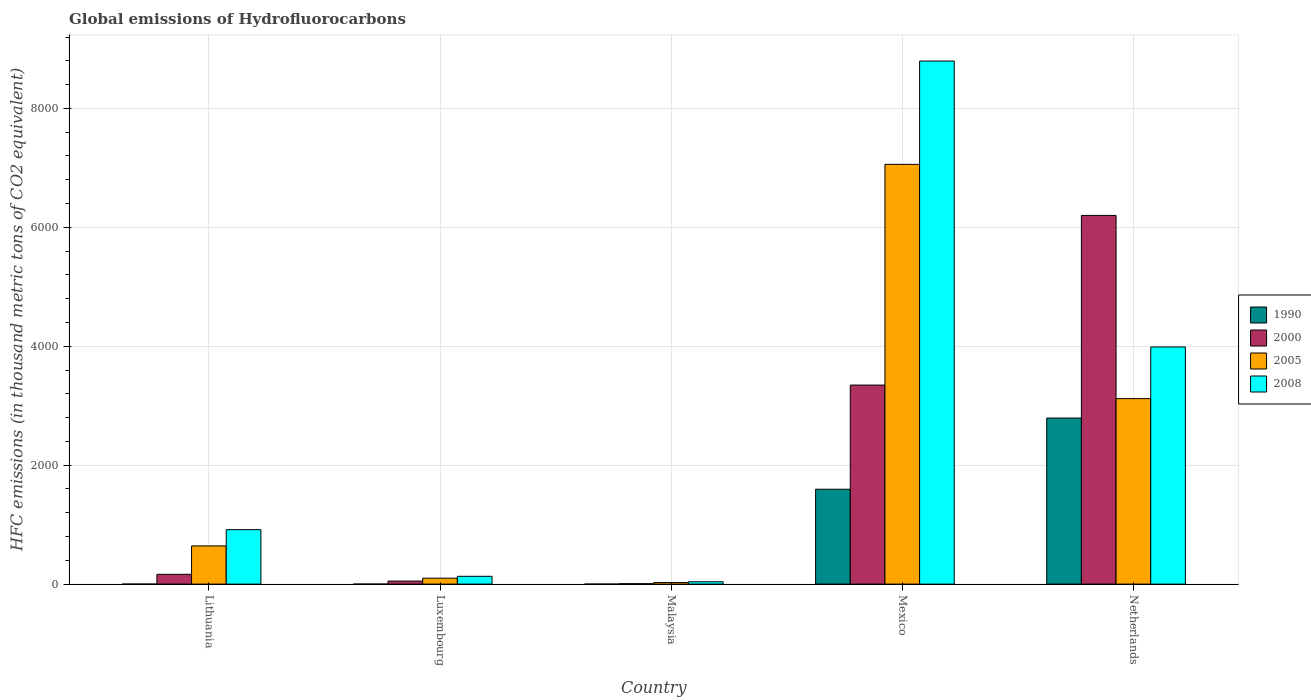Are the number of bars per tick equal to the number of legend labels?
Your response must be concise. Yes. What is the label of the 2nd group of bars from the left?
Your answer should be compact. Luxembourg. What is the global emissions of Hydrofluorocarbons in 2000 in Luxembourg?
Your answer should be compact. 51.1. Across all countries, what is the maximum global emissions of Hydrofluorocarbons in 2005?
Provide a succinct answer. 7058.9. In which country was the global emissions of Hydrofluorocarbons in 2008 minimum?
Keep it short and to the point. Malaysia. What is the total global emissions of Hydrofluorocarbons in 1990 in the graph?
Give a very brief answer. 4388.5. What is the difference between the global emissions of Hydrofluorocarbons in 1990 in Malaysia and that in Netherlands?
Give a very brief answer. -2792.8. What is the difference between the global emissions of Hydrofluorocarbons in 2008 in Malaysia and the global emissions of Hydrofluorocarbons in 2005 in Mexico?
Ensure brevity in your answer.  -7019.7. What is the average global emissions of Hydrofluorocarbons in 1990 per country?
Give a very brief answer. 877.7. What is the difference between the global emissions of Hydrofluorocarbons of/in 1990 and global emissions of Hydrofluorocarbons of/in 2000 in Malaysia?
Provide a succinct answer. -6.8. What is the ratio of the global emissions of Hydrofluorocarbons in 1990 in Lithuania to that in Netherlands?
Your answer should be very brief. 3.580507715994128e-5. Is the difference between the global emissions of Hydrofluorocarbons in 1990 in Luxembourg and Malaysia greater than the difference between the global emissions of Hydrofluorocarbons in 2000 in Luxembourg and Malaysia?
Offer a terse response. No. What is the difference between the highest and the second highest global emissions of Hydrofluorocarbons in 2005?
Your answer should be compact. 6416.8. What is the difference between the highest and the lowest global emissions of Hydrofluorocarbons in 2008?
Offer a terse response. 8757.7. In how many countries, is the global emissions of Hydrofluorocarbons in 2005 greater than the average global emissions of Hydrofluorocarbons in 2005 taken over all countries?
Make the answer very short. 2. What does the 2nd bar from the left in Lithuania represents?
Ensure brevity in your answer.  2000. How many bars are there?
Provide a short and direct response. 20. What is the difference between two consecutive major ticks on the Y-axis?
Provide a short and direct response. 2000. Does the graph contain any zero values?
Provide a short and direct response. No. What is the title of the graph?
Provide a succinct answer. Global emissions of Hydrofluorocarbons. What is the label or title of the Y-axis?
Make the answer very short. HFC emissions (in thousand metric tons of CO2 equivalent). What is the HFC emissions (in thousand metric tons of CO2 equivalent) of 1990 in Lithuania?
Your answer should be compact. 0.1. What is the HFC emissions (in thousand metric tons of CO2 equivalent) in 2000 in Lithuania?
Ensure brevity in your answer.  164.5. What is the HFC emissions (in thousand metric tons of CO2 equivalent) in 2005 in Lithuania?
Give a very brief answer. 642.1. What is the HFC emissions (in thousand metric tons of CO2 equivalent) in 2008 in Lithuania?
Provide a succinct answer. 915.7. What is the HFC emissions (in thousand metric tons of CO2 equivalent) of 1990 in Luxembourg?
Provide a short and direct response. 0.1. What is the HFC emissions (in thousand metric tons of CO2 equivalent) of 2000 in Luxembourg?
Your answer should be very brief. 51.1. What is the HFC emissions (in thousand metric tons of CO2 equivalent) in 2005 in Luxembourg?
Provide a succinct answer. 99.5. What is the HFC emissions (in thousand metric tons of CO2 equivalent) of 2008 in Luxembourg?
Provide a short and direct response. 131.2. What is the HFC emissions (in thousand metric tons of CO2 equivalent) of 1990 in Malaysia?
Provide a succinct answer. 0.1. What is the HFC emissions (in thousand metric tons of CO2 equivalent) in 2005 in Malaysia?
Offer a very short reply. 26.1. What is the HFC emissions (in thousand metric tons of CO2 equivalent) of 2008 in Malaysia?
Your answer should be very brief. 39.2. What is the HFC emissions (in thousand metric tons of CO2 equivalent) of 1990 in Mexico?
Make the answer very short. 1595.3. What is the HFC emissions (in thousand metric tons of CO2 equivalent) in 2000 in Mexico?
Keep it short and to the point. 3347.3. What is the HFC emissions (in thousand metric tons of CO2 equivalent) in 2005 in Mexico?
Make the answer very short. 7058.9. What is the HFC emissions (in thousand metric tons of CO2 equivalent) in 2008 in Mexico?
Offer a terse response. 8796.9. What is the HFC emissions (in thousand metric tons of CO2 equivalent) of 1990 in Netherlands?
Offer a very short reply. 2792.9. What is the HFC emissions (in thousand metric tons of CO2 equivalent) of 2000 in Netherlands?
Offer a terse response. 6200.4. What is the HFC emissions (in thousand metric tons of CO2 equivalent) in 2005 in Netherlands?
Provide a short and direct response. 3119.5. What is the HFC emissions (in thousand metric tons of CO2 equivalent) in 2008 in Netherlands?
Your answer should be compact. 3988.8. Across all countries, what is the maximum HFC emissions (in thousand metric tons of CO2 equivalent) in 1990?
Your response must be concise. 2792.9. Across all countries, what is the maximum HFC emissions (in thousand metric tons of CO2 equivalent) of 2000?
Give a very brief answer. 6200.4. Across all countries, what is the maximum HFC emissions (in thousand metric tons of CO2 equivalent) in 2005?
Ensure brevity in your answer.  7058.9. Across all countries, what is the maximum HFC emissions (in thousand metric tons of CO2 equivalent) of 2008?
Your response must be concise. 8796.9. Across all countries, what is the minimum HFC emissions (in thousand metric tons of CO2 equivalent) of 2005?
Your answer should be compact. 26.1. Across all countries, what is the minimum HFC emissions (in thousand metric tons of CO2 equivalent) in 2008?
Your answer should be very brief. 39.2. What is the total HFC emissions (in thousand metric tons of CO2 equivalent) in 1990 in the graph?
Offer a very short reply. 4388.5. What is the total HFC emissions (in thousand metric tons of CO2 equivalent) of 2000 in the graph?
Offer a terse response. 9770.2. What is the total HFC emissions (in thousand metric tons of CO2 equivalent) of 2005 in the graph?
Your answer should be compact. 1.09e+04. What is the total HFC emissions (in thousand metric tons of CO2 equivalent) in 2008 in the graph?
Your answer should be very brief. 1.39e+04. What is the difference between the HFC emissions (in thousand metric tons of CO2 equivalent) in 1990 in Lithuania and that in Luxembourg?
Make the answer very short. 0. What is the difference between the HFC emissions (in thousand metric tons of CO2 equivalent) in 2000 in Lithuania and that in Luxembourg?
Provide a short and direct response. 113.4. What is the difference between the HFC emissions (in thousand metric tons of CO2 equivalent) in 2005 in Lithuania and that in Luxembourg?
Give a very brief answer. 542.6. What is the difference between the HFC emissions (in thousand metric tons of CO2 equivalent) of 2008 in Lithuania and that in Luxembourg?
Your answer should be compact. 784.5. What is the difference between the HFC emissions (in thousand metric tons of CO2 equivalent) in 1990 in Lithuania and that in Malaysia?
Provide a short and direct response. 0. What is the difference between the HFC emissions (in thousand metric tons of CO2 equivalent) in 2000 in Lithuania and that in Malaysia?
Offer a terse response. 157.6. What is the difference between the HFC emissions (in thousand metric tons of CO2 equivalent) of 2005 in Lithuania and that in Malaysia?
Give a very brief answer. 616. What is the difference between the HFC emissions (in thousand metric tons of CO2 equivalent) in 2008 in Lithuania and that in Malaysia?
Offer a very short reply. 876.5. What is the difference between the HFC emissions (in thousand metric tons of CO2 equivalent) in 1990 in Lithuania and that in Mexico?
Your response must be concise. -1595.2. What is the difference between the HFC emissions (in thousand metric tons of CO2 equivalent) in 2000 in Lithuania and that in Mexico?
Your answer should be compact. -3182.8. What is the difference between the HFC emissions (in thousand metric tons of CO2 equivalent) in 2005 in Lithuania and that in Mexico?
Provide a succinct answer. -6416.8. What is the difference between the HFC emissions (in thousand metric tons of CO2 equivalent) in 2008 in Lithuania and that in Mexico?
Give a very brief answer. -7881.2. What is the difference between the HFC emissions (in thousand metric tons of CO2 equivalent) of 1990 in Lithuania and that in Netherlands?
Make the answer very short. -2792.8. What is the difference between the HFC emissions (in thousand metric tons of CO2 equivalent) of 2000 in Lithuania and that in Netherlands?
Make the answer very short. -6035.9. What is the difference between the HFC emissions (in thousand metric tons of CO2 equivalent) in 2005 in Lithuania and that in Netherlands?
Give a very brief answer. -2477.4. What is the difference between the HFC emissions (in thousand metric tons of CO2 equivalent) of 2008 in Lithuania and that in Netherlands?
Keep it short and to the point. -3073.1. What is the difference between the HFC emissions (in thousand metric tons of CO2 equivalent) of 1990 in Luxembourg and that in Malaysia?
Your response must be concise. 0. What is the difference between the HFC emissions (in thousand metric tons of CO2 equivalent) of 2000 in Luxembourg and that in Malaysia?
Provide a short and direct response. 44.2. What is the difference between the HFC emissions (in thousand metric tons of CO2 equivalent) in 2005 in Luxembourg and that in Malaysia?
Keep it short and to the point. 73.4. What is the difference between the HFC emissions (in thousand metric tons of CO2 equivalent) of 2008 in Luxembourg and that in Malaysia?
Ensure brevity in your answer.  92. What is the difference between the HFC emissions (in thousand metric tons of CO2 equivalent) in 1990 in Luxembourg and that in Mexico?
Provide a short and direct response. -1595.2. What is the difference between the HFC emissions (in thousand metric tons of CO2 equivalent) in 2000 in Luxembourg and that in Mexico?
Your answer should be very brief. -3296.2. What is the difference between the HFC emissions (in thousand metric tons of CO2 equivalent) of 2005 in Luxembourg and that in Mexico?
Your answer should be compact. -6959.4. What is the difference between the HFC emissions (in thousand metric tons of CO2 equivalent) of 2008 in Luxembourg and that in Mexico?
Your answer should be compact. -8665.7. What is the difference between the HFC emissions (in thousand metric tons of CO2 equivalent) of 1990 in Luxembourg and that in Netherlands?
Offer a very short reply. -2792.8. What is the difference between the HFC emissions (in thousand metric tons of CO2 equivalent) in 2000 in Luxembourg and that in Netherlands?
Ensure brevity in your answer.  -6149.3. What is the difference between the HFC emissions (in thousand metric tons of CO2 equivalent) in 2005 in Luxembourg and that in Netherlands?
Offer a very short reply. -3020. What is the difference between the HFC emissions (in thousand metric tons of CO2 equivalent) in 2008 in Luxembourg and that in Netherlands?
Your answer should be very brief. -3857.6. What is the difference between the HFC emissions (in thousand metric tons of CO2 equivalent) of 1990 in Malaysia and that in Mexico?
Offer a very short reply. -1595.2. What is the difference between the HFC emissions (in thousand metric tons of CO2 equivalent) of 2000 in Malaysia and that in Mexico?
Give a very brief answer. -3340.4. What is the difference between the HFC emissions (in thousand metric tons of CO2 equivalent) in 2005 in Malaysia and that in Mexico?
Provide a short and direct response. -7032.8. What is the difference between the HFC emissions (in thousand metric tons of CO2 equivalent) in 2008 in Malaysia and that in Mexico?
Keep it short and to the point. -8757.7. What is the difference between the HFC emissions (in thousand metric tons of CO2 equivalent) in 1990 in Malaysia and that in Netherlands?
Your answer should be very brief. -2792.8. What is the difference between the HFC emissions (in thousand metric tons of CO2 equivalent) in 2000 in Malaysia and that in Netherlands?
Give a very brief answer. -6193.5. What is the difference between the HFC emissions (in thousand metric tons of CO2 equivalent) of 2005 in Malaysia and that in Netherlands?
Your answer should be very brief. -3093.4. What is the difference between the HFC emissions (in thousand metric tons of CO2 equivalent) of 2008 in Malaysia and that in Netherlands?
Your response must be concise. -3949.6. What is the difference between the HFC emissions (in thousand metric tons of CO2 equivalent) of 1990 in Mexico and that in Netherlands?
Your answer should be compact. -1197.6. What is the difference between the HFC emissions (in thousand metric tons of CO2 equivalent) of 2000 in Mexico and that in Netherlands?
Make the answer very short. -2853.1. What is the difference between the HFC emissions (in thousand metric tons of CO2 equivalent) of 2005 in Mexico and that in Netherlands?
Your answer should be compact. 3939.4. What is the difference between the HFC emissions (in thousand metric tons of CO2 equivalent) in 2008 in Mexico and that in Netherlands?
Keep it short and to the point. 4808.1. What is the difference between the HFC emissions (in thousand metric tons of CO2 equivalent) in 1990 in Lithuania and the HFC emissions (in thousand metric tons of CO2 equivalent) in 2000 in Luxembourg?
Ensure brevity in your answer.  -51. What is the difference between the HFC emissions (in thousand metric tons of CO2 equivalent) of 1990 in Lithuania and the HFC emissions (in thousand metric tons of CO2 equivalent) of 2005 in Luxembourg?
Ensure brevity in your answer.  -99.4. What is the difference between the HFC emissions (in thousand metric tons of CO2 equivalent) in 1990 in Lithuania and the HFC emissions (in thousand metric tons of CO2 equivalent) in 2008 in Luxembourg?
Provide a succinct answer. -131.1. What is the difference between the HFC emissions (in thousand metric tons of CO2 equivalent) in 2000 in Lithuania and the HFC emissions (in thousand metric tons of CO2 equivalent) in 2008 in Luxembourg?
Make the answer very short. 33.3. What is the difference between the HFC emissions (in thousand metric tons of CO2 equivalent) in 2005 in Lithuania and the HFC emissions (in thousand metric tons of CO2 equivalent) in 2008 in Luxembourg?
Ensure brevity in your answer.  510.9. What is the difference between the HFC emissions (in thousand metric tons of CO2 equivalent) in 1990 in Lithuania and the HFC emissions (in thousand metric tons of CO2 equivalent) in 2000 in Malaysia?
Ensure brevity in your answer.  -6.8. What is the difference between the HFC emissions (in thousand metric tons of CO2 equivalent) in 1990 in Lithuania and the HFC emissions (in thousand metric tons of CO2 equivalent) in 2005 in Malaysia?
Provide a succinct answer. -26. What is the difference between the HFC emissions (in thousand metric tons of CO2 equivalent) in 1990 in Lithuania and the HFC emissions (in thousand metric tons of CO2 equivalent) in 2008 in Malaysia?
Offer a terse response. -39.1. What is the difference between the HFC emissions (in thousand metric tons of CO2 equivalent) of 2000 in Lithuania and the HFC emissions (in thousand metric tons of CO2 equivalent) of 2005 in Malaysia?
Your answer should be very brief. 138.4. What is the difference between the HFC emissions (in thousand metric tons of CO2 equivalent) in 2000 in Lithuania and the HFC emissions (in thousand metric tons of CO2 equivalent) in 2008 in Malaysia?
Your response must be concise. 125.3. What is the difference between the HFC emissions (in thousand metric tons of CO2 equivalent) in 2005 in Lithuania and the HFC emissions (in thousand metric tons of CO2 equivalent) in 2008 in Malaysia?
Give a very brief answer. 602.9. What is the difference between the HFC emissions (in thousand metric tons of CO2 equivalent) in 1990 in Lithuania and the HFC emissions (in thousand metric tons of CO2 equivalent) in 2000 in Mexico?
Make the answer very short. -3347.2. What is the difference between the HFC emissions (in thousand metric tons of CO2 equivalent) in 1990 in Lithuania and the HFC emissions (in thousand metric tons of CO2 equivalent) in 2005 in Mexico?
Make the answer very short. -7058.8. What is the difference between the HFC emissions (in thousand metric tons of CO2 equivalent) of 1990 in Lithuania and the HFC emissions (in thousand metric tons of CO2 equivalent) of 2008 in Mexico?
Keep it short and to the point. -8796.8. What is the difference between the HFC emissions (in thousand metric tons of CO2 equivalent) in 2000 in Lithuania and the HFC emissions (in thousand metric tons of CO2 equivalent) in 2005 in Mexico?
Your answer should be very brief. -6894.4. What is the difference between the HFC emissions (in thousand metric tons of CO2 equivalent) in 2000 in Lithuania and the HFC emissions (in thousand metric tons of CO2 equivalent) in 2008 in Mexico?
Ensure brevity in your answer.  -8632.4. What is the difference between the HFC emissions (in thousand metric tons of CO2 equivalent) in 2005 in Lithuania and the HFC emissions (in thousand metric tons of CO2 equivalent) in 2008 in Mexico?
Your answer should be compact. -8154.8. What is the difference between the HFC emissions (in thousand metric tons of CO2 equivalent) in 1990 in Lithuania and the HFC emissions (in thousand metric tons of CO2 equivalent) in 2000 in Netherlands?
Offer a very short reply. -6200.3. What is the difference between the HFC emissions (in thousand metric tons of CO2 equivalent) in 1990 in Lithuania and the HFC emissions (in thousand metric tons of CO2 equivalent) in 2005 in Netherlands?
Provide a succinct answer. -3119.4. What is the difference between the HFC emissions (in thousand metric tons of CO2 equivalent) in 1990 in Lithuania and the HFC emissions (in thousand metric tons of CO2 equivalent) in 2008 in Netherlands?
Ensure brevity in your answer.  -3988.7. What is the difference between the HFC emissions (in thousand metric tons of CO2 equivalent) of 2000 in Lithuania and the HFC emissions (in thousand metric tons of CO2 equivalent) of 2005 in Netherlands?
Keep it short and to the point. -2955. What is the difference between the HFC emissions (in thousand metric tons of CO2 equivalent) of 2000 in Lithuania and the HFC emissions (in thousand metric tons of CO2 equivalent) of 2008 in Netherlands?
Ensure brevity in your answer.  -3824.3. What is the difference between the HFC emissions (in thousand metric tons of CO2 equivalent) in 2005 in Lithuania and the HFC emissions (in thousand metric tons of CO2 equivalent) in 2008 in Netherlands?
Your answer should be very brief. -3346.7. What is the difference between the HFC emissions (in thousand metric tons of CO2 equivalent) of 1990 in Luxembourg and the HFC emissions (in thousand metric tons of CO2 equivalent) of 2000 in Malaysia?
Offer a terse response. -6.8. What is the difference between the HFC emissions (in thousand metric tons of CO2 equivalent) in 1990 in Luxembourg and the HFC emissions (in thousand metric tons of CO2 equivalent) in 2005 in Malaysia?
Make the answer very short. -26. What is the difference between the HFC emissions (in thousand metric tons of CO2 equivalent) of 1990 in Luxembourg and the HFC emissions (in thousand metric tons of CO2 equivalent) of 2008 in Malaysia?
Provide a succinct answer. -39.1. What is the difference between the HFC emissions (in thousand metric tons of CO2 equivalent) of 2000 in Luxembourg and the HFC emissions (in thousand metric tons of CO2 equivalent) of 2008 in Malaysia?
Offer a terse response. 11.9. What is the difference between the HFC emissions (in thousand metric tons of CO2 equivalent) of 2005 in Luxembourg and the HFC emissions (in thousand metric tons of CO2 equivalent) of 2008 in Malaysia?
Make the answer very short. 60.3. What is the difference between the HFC emissions (in thousand metric tons of CO2 equivalent) in 1990 in Luxembourg and the HFC emissions (in thousand metric tons of CO2 equivalent) in 2000 in Mexico?
Provide a short and direct response. -3347.2. What is the difference between the HFC emissions (in thousand metric tons of CO2 equivalent) in 1990 in Luxembourg and the HFC emissions (in thousand metric tons of CO2 equivalent) in 2005 in Mexico?
Offer a very short reply. -7058.8. What is the difference between the HFC emissions (in thousand metric tons of CO2 equivalent) in 1990 in Luxembourg and the HFC emissions (in thousand metric tons of CO2 equivalent) in 2008 in Mexico?
Your answer should be very brief. -8796.8. What is the difference between the HFC emissions (in thousand metric tons of CO2 equivalent) in 2000 in Luxembourg and the HFC emissions (in thousand metric tons of CO2 equivalent) in 2005 in Mexico?
Keep it short and to the point. -7007.8. What is the difference between the HFC emissions (in thousand metric tons of CO2 equivalent) of 2000 in Luxembourg and the HFC emissions (in thousand metric tons of CO2 equivalent) of 2008 in Mexico?
Provide a succinct answer. -8745.8. What is the difference between the HFC emissions (in thousand metric tons of CO2 equivalent) in 2005 in Luxembourg and the HFC emissions (in thousand metric tons of CO2 equivalent) in 2008 in Mexico?
Offer a very short reply. -8697.4. What is the difference between the HFC emissions (in thousand metric tons of CO2 equivalent) in 1990 in Luxembourg and the HFC emissions (in thousand metric tons of CO2 equivalent) in 2000 in Netherlands?
Your answer should be compact. -6200.3. What is the difference between the HFC emissions (in thousand metric tons of CO2 equivalent) in 1990 in Luxembourg and the HFC emissions (in thousand metric tons of CO2 equivalent) in 2005 in Netherlands?
Provide a short and direct response. -3119.4. What is the difference between the HFC emissions (in thousand metric tons of CO2 equivalent) of 1990 in Luxembourg and the HFC emissions (in thousand metric tons of CO2 equivalent) of 2008 in Netherlands?
Ensure brevity in your answer.  -3988.7. What is the difference between the HFC emissions (in thousand metric tons of CO2 equivalent) of 2000 in Luxembourg and the HFC emissions (in thousand metric tons of CO2 equivalent) of 2005 in Netherlands?
Your answer should be compact. -3068.4. What is the difference between the HFC emissions (in thousand metric tons of CO2 equivalent) of 2000 in Luxembourg and the HFC emissions (in thousand metric tons of CO2 equivalent) of 2008 in Netherlands?
Offer a very short reply. -3937.7. What is the difference between the HFC emissions (in thousand metric tons of CO2 equivalent) of 2005 in Luxembourg and the HFC emissions (in thousand metric tons of CO2 equivalent) of 2008 in Netherlands?
Your answer should be very brief. -3889.3. What is the difference between the HFC emissions (in thousand metric tons of CO2 equivalent) of 1990 in Malaysia and the HFC emissions (in thousand metric tons of CO2 equivalent) of 2000 in Mexico?
Give a very brief answer. -3347.2. What is the difference between the HFC emissions (in thousand metric tons of CO2 equivalent) in 1990 in Malaysia and the HFC emissions (in thousand metric tons of CO2 equivalent) in 2005 in Mexico?
Make the answer very short. -7058.8. What is the difference between the HFC emissions (in thousand metric tons of CO2 equivalent) in 1990 in Malaysia and the HFC emissions (in thousand metric tons of CO2 equivalent) in 2008 in Mexico?
Your answer should be very brief. -8796.8. What is the difference between the HFC emissions (in thousand metric tons of CO2 equivalent) in 2000 in Malaysia and the HFC emissions (in thousand metric tons of CO2 equivalent) in 2005 in Mexico?
Provide a succinct answer. -7052. What is the difference between the HFC emissions (in thousand metric tons of CO2 equivalent) of 2000 in Malaysia and the HFC emissions (in thousand metric tons of CO2 equivalent) of 2008 in Mexico?
Your answer should be very brief. -8790. What is the difference between the HFC emissions (in thousand metric tons of CO2 equivalent) of 2005 in Malaysia and the HFC emissions (in thousand metric tons of CO2 equivalent) of 2008 in Mexico?
Make the answer very short. -8770.8. What is the difference between the HFC emissions (in thousand metric tons of CO2 equivalent) in 1990 in Malaysia and the HFC emissions (in thousand metric tons of CO2 equivalent) in 2000 in Netherlands?
Your answer should be very brief. -6200.3. What is the difference between the HFC emissions (in thousand metric tons of CO2 equivalent) in 1990 in Malaysia and the HFC emissions (in thousand metric tons of CO2 equivalent) in 2005 in Netherlands?
Make the answer very short. -3119.4. What is the difference between the HFC emissions (in thousand metric tons of CO2 equivalent) in 1990 in Malaysia and the HFC emissions (in thousand metric tons of CO2 equivalent) in 2008 in Netherlands?
Make the answer very short. -3988.7. What is the difference between the HFC emissions (in thousand metric tons of CO2 equivalent) of 2000 in Malaysia and the HFC emissions (in thousand metric tons of CO2 equivalent) of 2005 in Netherlands?
Your answer should be compact. -3112.6. What is the difference between the HFC emissions (in thousand metric tons of CO2 equivalent) in 2000 in Malaysia and the HFC emissions (in thousand metric tons of CO2 equivalent) in 2008 in Netherlands?
Provide a short and direct response. -3981.9. What is the difference between the HFC emissions (in thousand metric tons of CO2 equivalent) of 2005 in Malaysia and the HFC emissions (in thousand metric tons of CO2 equivalent) of 2008 in Netherlands?
Provide a short and direct response. -3962.7. What is the difference between the HFC emissions (in thousand metric tons of CO2 equivalent) in 1990 in Mexico and the HFC emissions (in thousand metric tons of CO2 equivalent) in 2000 in Netherlands?
Provide a short and direct response. -4605.1. What is the difference between the HFC emissions (in thousand metric tons of CO2 equivalent) in 1990 in Mexico and the HFC emissions (in thousand metric tons of CO2 equivalent) in 2005 in Netherlands?
Make the answer very short. -1524.2. What is the difference between the HFC emissions (in thousand metric tons of CO2 equivalent) in 1990 in Mexico and the HFC emissions (in thousand metric tons of CO2 equivalent) in 2008 in Netherlands?
Ensure brevity in your answer.  -2393.5. What is the difference between the HFC emissions (in thousand metric tons of CO2 equivalent) of 2000 in Mexico and the HFC emissions (in thousand metric tons of CO2 equivalent) of 2005 in Netherlands?
Make the answer very short. 227.8. What is the difference between the HFC emissions (in thousand metric tons of CO2 equivalent) in 2000 in Mexico and the HFC emissions (in thousand metric tons of CO2 equivalent) in 2008 in Netherlands?
Give a very brief answer. -641.5. What is the difference between the HFC emissions (in thousand metric tons of CO2 equivalent) in 2005 in Mexico and the HFC emissions (in thousand metric tons of CO2 equivalent) in 2008 in Netherlands?
Make the answer very short. 3070.1. What is the average HFC emissions (in thousand metric tons of CO2 equivalent) in 1990 per country?
Your response must be concise. 877.7. What is the average HFC emissions (in thousand metric tons of CO2 equivalent) of 2000 per country?
Ensure brevity in your answer.  1954.04. What is the average HFC emissions (in thousand metric tons of CO2 equivalent) in 2005 per country?
Your response must be concise. 2189.22. What is the average HFC emissions (in thousand metric tons of CO2 equivalent) in 2008 per country?
Your response must be concise. 2774.36. What is the difference between the HFC emissions (in thousand metric tons of CO2 equivalent) of 1990 and HFC emissions (in thousand metric tons of CO2 equivalent) of 2000 in Lithuania?
Keep it short and to the point. -164.4. What is the difference between the HFC emissions (in thousand metric tons of CO2 equivalent) of 1990 and HFC emissions (in thousand metric tons of CO2 equivalent) of 2005 in Lithuania?
Ensure brevity in your answer.  -642. What is the difference between the HFC emissions (in thousand metric tons of CO2 equivalent) in 1990 and HFC emissions (in thousand metric tons of CO2 equivalent) in 2008 in Lithuania?
Give a very brief answer. -915.6. What is the difference between the HFC emissions (in thousand metric tons of CO2 equivalent) of 2000 and HFC emissions (in thousand metric tons of CO2 equivalent) of 2005 in Lithuania?
Make the answer very short. -477.6. What is the difference between the HFC emissions (in thousand metric tons of CO2 equivalent) of 2000 and HFC emissions (in thousand metric tons of CO2 equivalent) of 2008 in Lithuania?
Your answer should be very brief. -751.2. What is the difference between the HFC emissions (in thousand metric tons of CO2 equivalent) of 2005 and HFC emissions (in thousand metric tons of CO2 equivalent) of 2008 in Lithuania?
Provide a short and direct response. -273.6. What is the difference between the HFC emissions (in thousand metric tons of CO2 equivalent) in 1990 and HFC emissions (in thousand metric tons of CO2 equivalent) in 2000 in Luxembourg?
Ensure brevity in your answer.  -51. What is the difference between the HFC emissions (in thousand metric tons of CO2 equivalent) of 1990 and HFC emissions (in thousand metric tons of CO2 equivalent) of 2005 in Luxembourg?
Your answer should be compact. -99.4. What is the difference between the HFC emissions (in thousand metric tons of CO2 equivalent) of 1990 and HFC emissions (in thousand metric tons of CO2 equivalent) of 2008 in Luxembourg?
Ensure brevity in your answer.  -131.1. What is the difference between the HFC emissions (in thousand metric tons of CO2 equivalent) of 2000 and HFC emissions (in thousand metric tons of CO2 equivalent) of 2005 in Luxembourg?
Your answer should be compact. -48.4. What is the difference between the HFC emissions (in thousand metric tons of CO2 equivalent) in 2000 and HFC emissions (in thousand metric tons of CO2 equivalent) in 2008 in Luxembourg?
Make the answer very short. -80.1. What is the difference between the HFC emissions (in thousand metric tons of CO2 equivalent) in 2005 and HFC emissions (in thousand metric tons of CO2 equivalent) in 2008 in Luxembourg?
Ensure brevity in your answer.  -31.7. What is the difference between the HFC emissions (in thousand metric tons of CO2 equivalent) in 1990 and HFC emissions (in thousand metric tons of CO2 equivalent) in 2000 in Malaysia?
Keep it short and to the point. -6.8. What is the difference between the HFC emissions (in thousand metric tons of CO2 equivalent) in 1990 and HFC emissions (in thousand metric tons of CO2 equivalent) in 2005 in Malaysia?
Ensure brevity in your answer.  -26. What is the difference between the HFC emissions (in thousand metric tons of CO2 equivalent) of 1990 and HFC emissions (in thousand metric tons of CO2 equivalent) of 2008 in Malaysia?
Your response must be concise. -39.1. What is the difference between the HFC emissions (in thousand metric tons of CO2 equivalent) of 2000 and HFC emissions (in thousand metric tons of CO2 equivalent) of 2005 in Malaysia?
Provide a short and direct response. -19.2. What is the difference between the HFC emissions (in thousand metric tons of CO2 equivalent) of 2000 and HFC emissions (in thousand metric tons of CO2 equivalent) of 2008 in Malaysia?
Keep it short and to the point. -32.3. What is the difference between the HFC emissions (in thousand metric tons of CO2 equivalent) in 1990 and HFC emissions (in thousand metric tons of CO2 equivalent) in 2000 in Mexico?
Keep it short and to the point. -1752. What is the difference between the HFC emissions (in thousand metric tons of CO2 equivalent) in 1990 and HFC emissions (in thousand metric tons of CO2 equivalent) in 2005 in Mexico?
Provide a succinct answer. -5463.6. What is the difference between the HFC emissions (in thousand metric tons of CO2 equivalent) in 1990 and HFC emissions (in thousand metric tons of CO2 equivalent) in 2008 in Mexico?
Make the answer very short. -7201.6. What is the difference between the HFC emissions (in thousand metric tons of CO2 equivalent) in 2000 and HFC emissions (in thousand metric tons of CO2 equivalent) in 2005 in Mexico?
Your answer should be compact. -3711.6. What is the difference between the HFC emissions (in thousand metric tons of CO2 equivalent) of 2000 and HFC emissions (in thousand metric tons of CO2 equivalent) of 2008 in Mexico?
Your answer should be compact. -5449.6. What is the difference between the HFC emissions (in thousand metric tons of CO2 equivalent) of 2005 and HFC emissions (in thousand metric tons of CO2 equivalent) of 2008 in Mexico?
Offer a terse response. -1738. What is the difference between the HFC emissions (in thousand metric tons of CO2 equivalent) of 1990 and HFC emissions (in thousand metric tons of CO2 equivalent) of 2000 in Netherlands?
Give a very brief answer. -3407.5. What is the difference between the HFC emissions (in thousand metric tons of CO2 equivalent) of 1990 and HFC emissions (in thousand metric tons of CO2 equivalent) of 2005 in Netherlands?
Keep it short and to the point. -326.6. What is the difference between the HFC emissions (in thousand metric tons of CO2 equivalent) of 1990 and HFC emissions (in thousand metric tons of CO2 equivalent) of 2008 in Netherlands?
Your answer should be compact. -1195.9. What is the difference between the HFC emissions (in thousand metric tons of CO2 equivalent) in 2000 and HFC emissions (in thousand metric tons of CO2 equivalent) in 2005 in Netherlands?
Offer a very short reply. 3080.9. What is the difference between the HFC emissions (in thousand metric tons of CO2 equivalent) of 2000 and HFC emissions (in thousand metric tons of CO2 equivalent) of 2008 in Netherlands?
Make the answer very short. 2211.6. What is the difference between the HFC emissions (in thousand metric tons of CO2 equivalent) in 2005 and HFC emissions (in thousand metric tons of CO2 equivalent) in 2008 in Netherlands?
Provide a short and direct response. -869.3. What is the ratio of the HFC emissions (in thousand metric tons of CO2 equivalent) of 2000 in Lithuania to that in Luxembourg?
Give a very brief answer. 3.22. What is the ratio of the HFC emissions (in thousand metric tons of CO2 equivalent) in 2005 in Lithuania to that in Luxembourg?
Your answer should be compact. 6.45. What is the ratio of the HFC emissions (in thousand metric tons of CO2 equivalent) of 2008 in Lithuania to that in Luxembourg?
Ensure brevity in your answer.  6.98. What is the ratio of the HFC emissions (in thousand metric tons of CO2 equivalent) of 2000 in Lithuania to that in Malaysia?
Give a very brief answer. 23.84. What is the ratio of the HFC emissions (in thousand metric tons of CO2 equivalent) in 2005 in Lithuania to that in Malaysia?
Keep it short and to the point. 24.6. What is the ratio of the HFC emissions (in thousand metric tons of CO2 equivalent) of 2008 in Lithuania to that in Malaysia?
Your answer should be compact. 23.36. What is the ratio of the HFC emissions (in thousand metric tons of CO2 equivalent) in 1990 in Lithuania to that in Mexico?
Your response must be concise. 0. What is the ratio of the HFC emissions (in thousand metric tons of CO2 equivalent) of 2000 in Lithuania to that in Mexico?
Your answer should be compact. 0.05. What is the ratio of the HFC emissions (in thousand metric tons of CO2 equivalent) in 2005 in Lithuania to that in Mexico?
Offer a terse response. 0.09. What is the ratio of the HFC emissions (in thousand metric tons of CO2 equivalent) of 2008 in Lithuania to that in Mexico?
Your response must be concise. 0.1. What is the ratio of the HFC emissions (in thousand metric tons of CO2 equivalent) of 1990 in Lithuania to that in Netherlands?
Your response must be concise. 0. What is the ratio of the HFC emissions (in thousand metric tons of CO2 equivalent) of 2000 in Lithuania to that in Netherlands?
Your response must be concise. 0.03. What is the ratio of the HFC emissions (in thousand metric tons of CO2 equivalent) of 2005 in Lithuania to that in Netherlands?
Your answer should be compact. 0.21. What is the ratio of the HFC emissions (in thousand metric tons of CO2 equivalent) in 2008 in Lithuania to that in Netherlands?
Make the answer very short. 0.23. What is the ratio of the HFC emissions (in thousand metric tons of CO2 equivalent) of 2000 in Luxembourg to that in Malaysia?
Your answer should be very brief. 7.41. What is the ratio of the HFC emissions (in thousand metric tons of CO2 equivalent) in 2005 in Luxembourg to that in Malaysia?
Make the answer very short. 3.81. What is the ratio of the HFC emissions (in thousand metric tons of CO2 equivalent) of 2008 in Luxembourg to that in Malaysia?
Your answer should be very brief. 3.35. What is the ratio of the HFC emissions (in thousand metric tons of CO2 equivalent) of 2000 in Luxembourg to that in Mexico?
Offer a very short reply. 0.02. What is the ratio of the HFC emissions (in thousand metric tons of CO2 equivalent) in 2005 in Luxembourg to that in Mexico?
Offer a very short reply. 0.01. What is the ratio of the HFC emissions (in thousand metric tons of CO2 equivalent) in 2008 in Luxembourg to that in Mexico?
Provide a short and direct response. 0.01. What is the ratio of the HFC emissions (in thousand metric tons of CO2 equivalent) in 1990 in Luxembourg to that in Netherlands?
Provide a short and direct response. 0. What is the ratio of the HFC emissions (in thousand metric tons of CO2 equivalent) of 2000 in Luxembourg to that in Netherlands?
Make the answer very short. 0.01. What is the ratio of the HFC emissions (in thousand metric tons of CO2 equivalent) of 2005 in Luxembourg to that in Netherlands?
Give a very brief answer. 0.03. What is the ratio of the HFC emissions (in thousand metric tons of CO2 equivalent) in 2008 in Luxembourg to that in Netherlands?
Ensure brevity in your answer.  0.03. What is the ratio of the HFC emissions (in thousand metric tons of CO2 equivalent) in 1990 in Malaysia to that in Mexico?
Offer a very short reply. 0. What is the ratio of the HFC emissions (in thousand metric tons of CO2 equivalent) in 2000 in Malaysia to that in Mexico?
Your answer should be very brief. 0. What is the ratio of the HFC emissions (in thousand metric tons of CO2 equivalent) of 2005 in Malaysia to that in Mexico?
Provide a short and direct response. 0. What is the ratio of the HFC emissions (in thousand metric tons of CO2 equivalent) in 2008 in Malaysia to that in Mexico?
Your answer should be compact. 0. What is the ratio of the HFC emissions (in thousand metric tons of CO2 equivalent) in 2000 in Malaysia to that in Netherlands?
Your answer should be compact. 0. What is the ratio of the HFC emissions (in thousand metric tons of CO2 equivalent) in 2005 in Malaysia to that in Netherlands?
Offer a terse response. 0.01. What is the ratio of the HFC emissions (in thousand metric tons of CO2 equivalent) of 2008 in Malaysia to that in Netherlands?
Your answer should be very brief. 0.01. What is the ratio of the HFC emissions (in thousand metric tons of CO2 equivalent) of 1990 in Mexico to that in Netherlands?
Your response must be concise. 0.57. What is the ratio of the HFC emissions (in thousand metric tons of CO2 equivalent) of 2000 in Mexico to that in Netherlands?
Offer a very short reply. 0.54. What is the ratio of the HFC emissions (in thousand metric tons of CO2 equivalent) in 2005 in Mexico to that in Netherlands?
Make the answer very short. 2.26. What is the ratio of the HFC emissions (in thousand metric tons of CO2 equivalent) of 2008 in Mexico to that in Netherlands?
Provide a succinct answer. 2.21. What is the difference between the highest and the second highest HFC emissions (in thousand metric tons of CO2 equivalent) in 1990?
Your response must be concise. 1197.6. What is the difference between the highest and the second highest HFC emissions (in thousand metric tons of CO2 equivalent) of 2000?
Ensure brevity in your answer.  2853.1. What is the difference between the highest and the second highest HFC emissions (in thousand metric tons of CO2 equivalent) in 2005?
Offer a very short reply. 3939.4. What is the difference between the highest and the second highest HFC emissions (in thousand metric tons of CO2 equivalent) in 2008?
Keep it short and to the point. 4808.1. What is the difference between the highest and the lowest HFC emissions (in thousand metric tons of CO2 equivalent) in 1990?
Provide a succinct answer. 2792.8. What is the difference between the highest and the lowest HFC emissions (in thousand metric tons of CO2 equivalent) in 2000?
Keep it short and to the point. 6193.5. What is the difference between the highest and the lowest HFC emissions (in thousand metric tons of CO2 equivalent) in 2005?
Your answer should be very brief. 7032.8. What is the difference between the highest and the lowest HFC emissions (in thousand metric tons of CO2 equivalent) in 2008?
Your answer should be compact. 8757.7. 